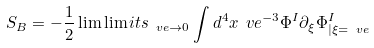<formula> <loc_0><loc_0><loc_500><loc_500>S _ { B } = - \frac { 1 } { 2 } \lim \lim i t s _ { \ v e \to 0 } \int d ^ { 4 } x \ v e ^ { - 3 } \Phi ^ { I } \partial _ { \xi } \Phi ^ { I } _ { | \xi = \ v e }</formula> 